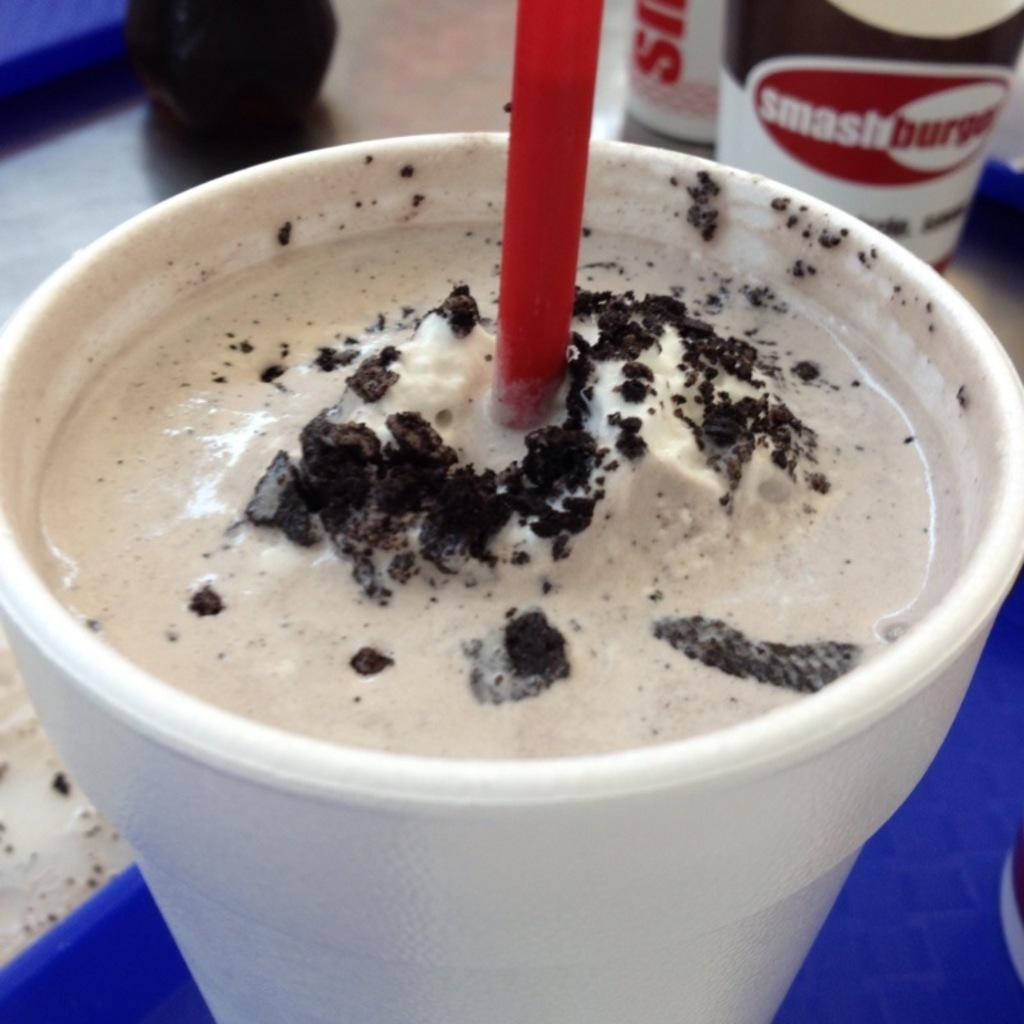What is in the glass that is visible in the image? There is a glass containing milkshake in the image. How might someone consume the milkshake in the image? There is a straw in the glass, which can be used to drink the milkshake. Where is the glass located in the image? The glass is on a table. What type of attraction is visible in the background of the image? There is no attraction visible in the background of the image; it only features a glass containing milkshake, a straw, and a table. 